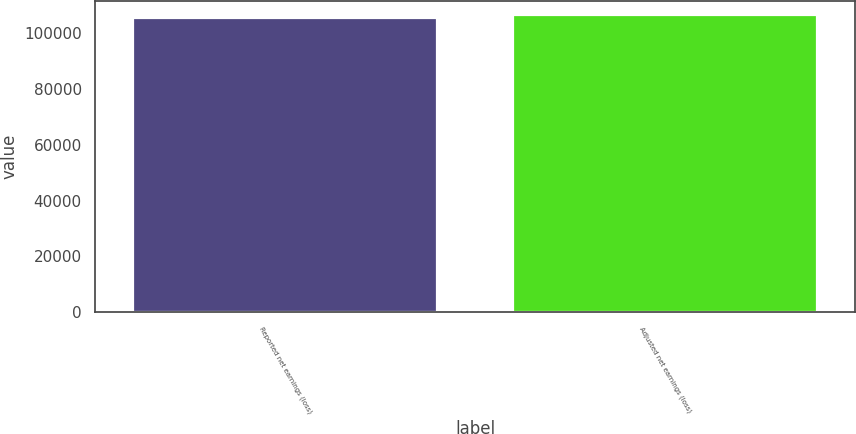Convert chart to OTSL. <chart><loc_0><loc_0><loc_500><loc_500><bar_chart><fcel>Reported net earnings (loss)<fcel>Adjusted net earnings (loss)<nl><fcel>105265<fcel>106280<nl></chart> 